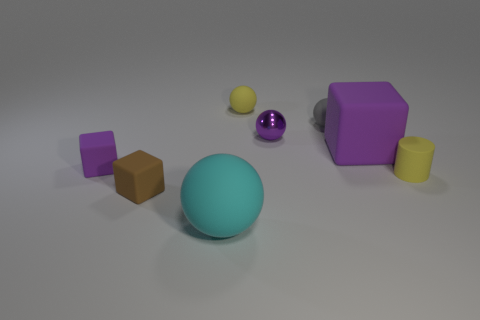How many things are either metal balls or yellow rubber things?
Offer a very short reply. 3. How many small purple things are made of the same material as the small brown thing?
Your response must be concise. 1. What size is the cyan thing that is the same shape as the tiny gray rubber thing?
Offer a very short reply. Large. There is a large cyan rubber sphere; are there any large objects to the left of it?
Provide a succinct answer. No. What is the big purple block made of?
Offer a terse response. Rubber. There is a large rubber thing left of the metal thing; is it the same color as the shiny thing?
Make the answer very short. No. Is there any other thing that has the same shape as the gray object?
Keep it short and to the point. Yes. The other small rubber thing that is the same shape as the small gray rubber thing is what color?
Offer a very short reply. Yellow. There is a tiny yellow thing that is behind the gray rubber sphere; what is it made of?
Keep it short and to the point. Rubber. What color is the metallic ball?
Make the answer very short. Purple. 